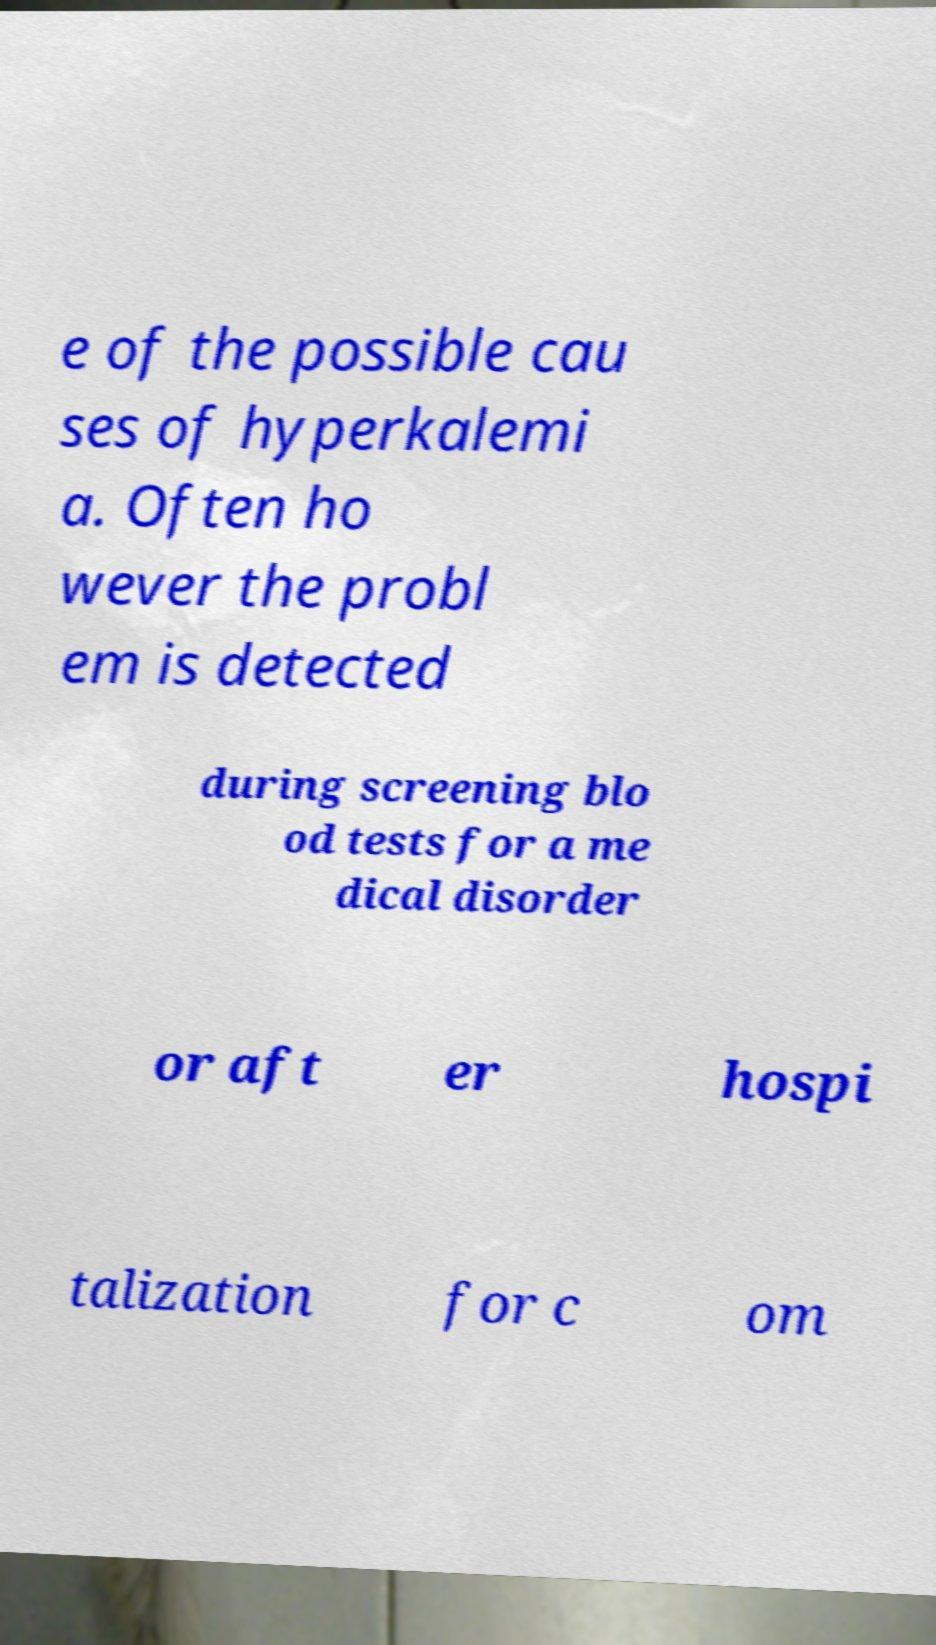I need the written content from this picture converted into text. Can you do that? e of the possible cau ses of hyperkalemi a. Often ho wever the probl em is detected during screening blo od tests for a me dical disorder or aft er hospi talization for c om 